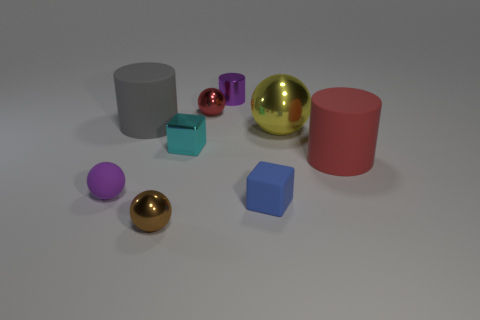Is the size of the blue block in front of the big red matte cylinder the same as the cylinder that is to the left of the small brown metallic thing?
Give a very brief answer. No. Are there any big gray cylinders made of the same material as the small brown object?
Give a very brief answer. No. The metallic object that is the same color as the rubber ball is what size?
Make the answer very short. Small. There is a big matte object right of the metallic sphere in front of the big yellow ball; is there a purple cylinder that is in front of it?
Provide a succinct answer. No. There is a gray rubber object; are there any tiny rubber balls to the right of it?
Keep it short and to the point. No. What number of tiny rubber things are right of the small rubber object left of the small blue block?
Make the answer very short. 1. There is a gray rubber cylinder; is it the same size as the red object that is to the right of the yellow object?
Your answer should be compact. Yes. Is there a rubber block of the same color as the tiny metallic cylinder?
Keep it short and to the point. No. There is a block that is made of the same material as the tiny red ball; what is its size?
Provide a short and direct response. Small. Does the tiny cylinder have the same material as the tiny cyan thing?
Give a very brief answer. Yes. 